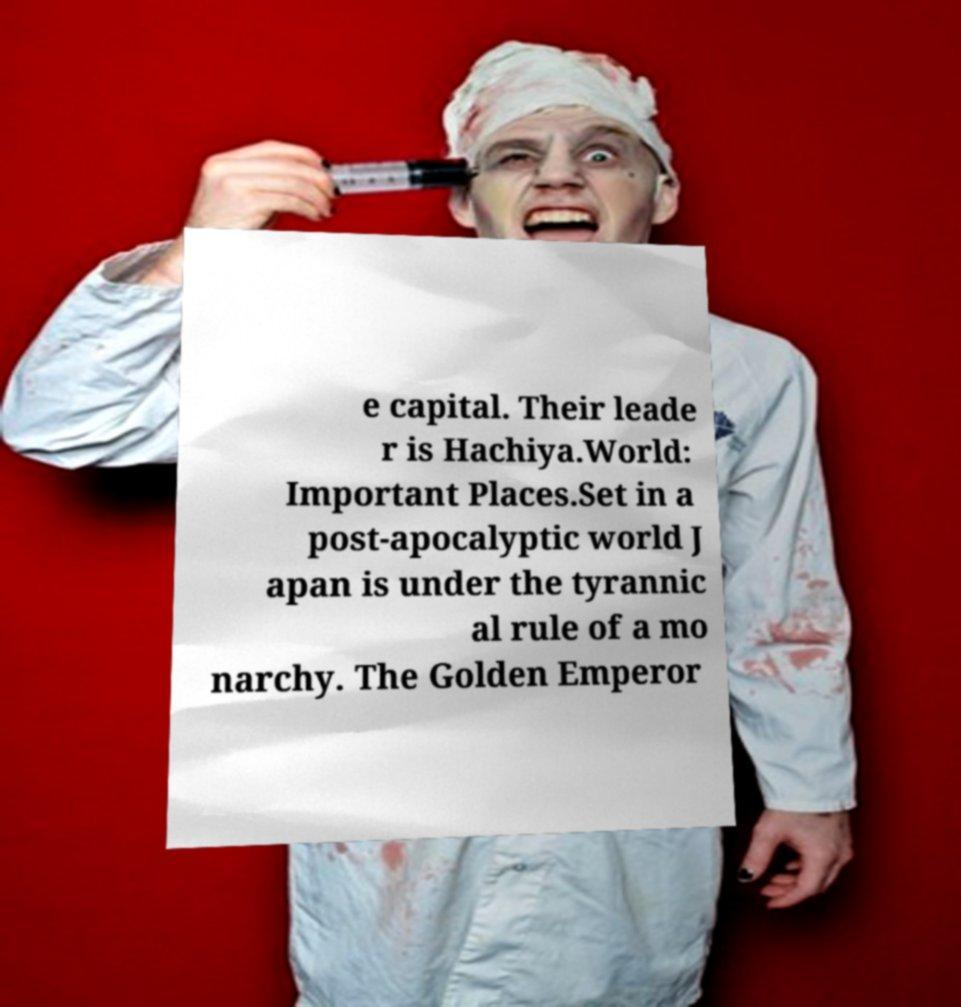Please identify and transcribe the text found in this image. e capital. Their leade r is Hachiya.World: Important Places.Set in a post-apocalyptic world J apan is under the tyrannic al rule of a mo narchy. The Golden Emperor 